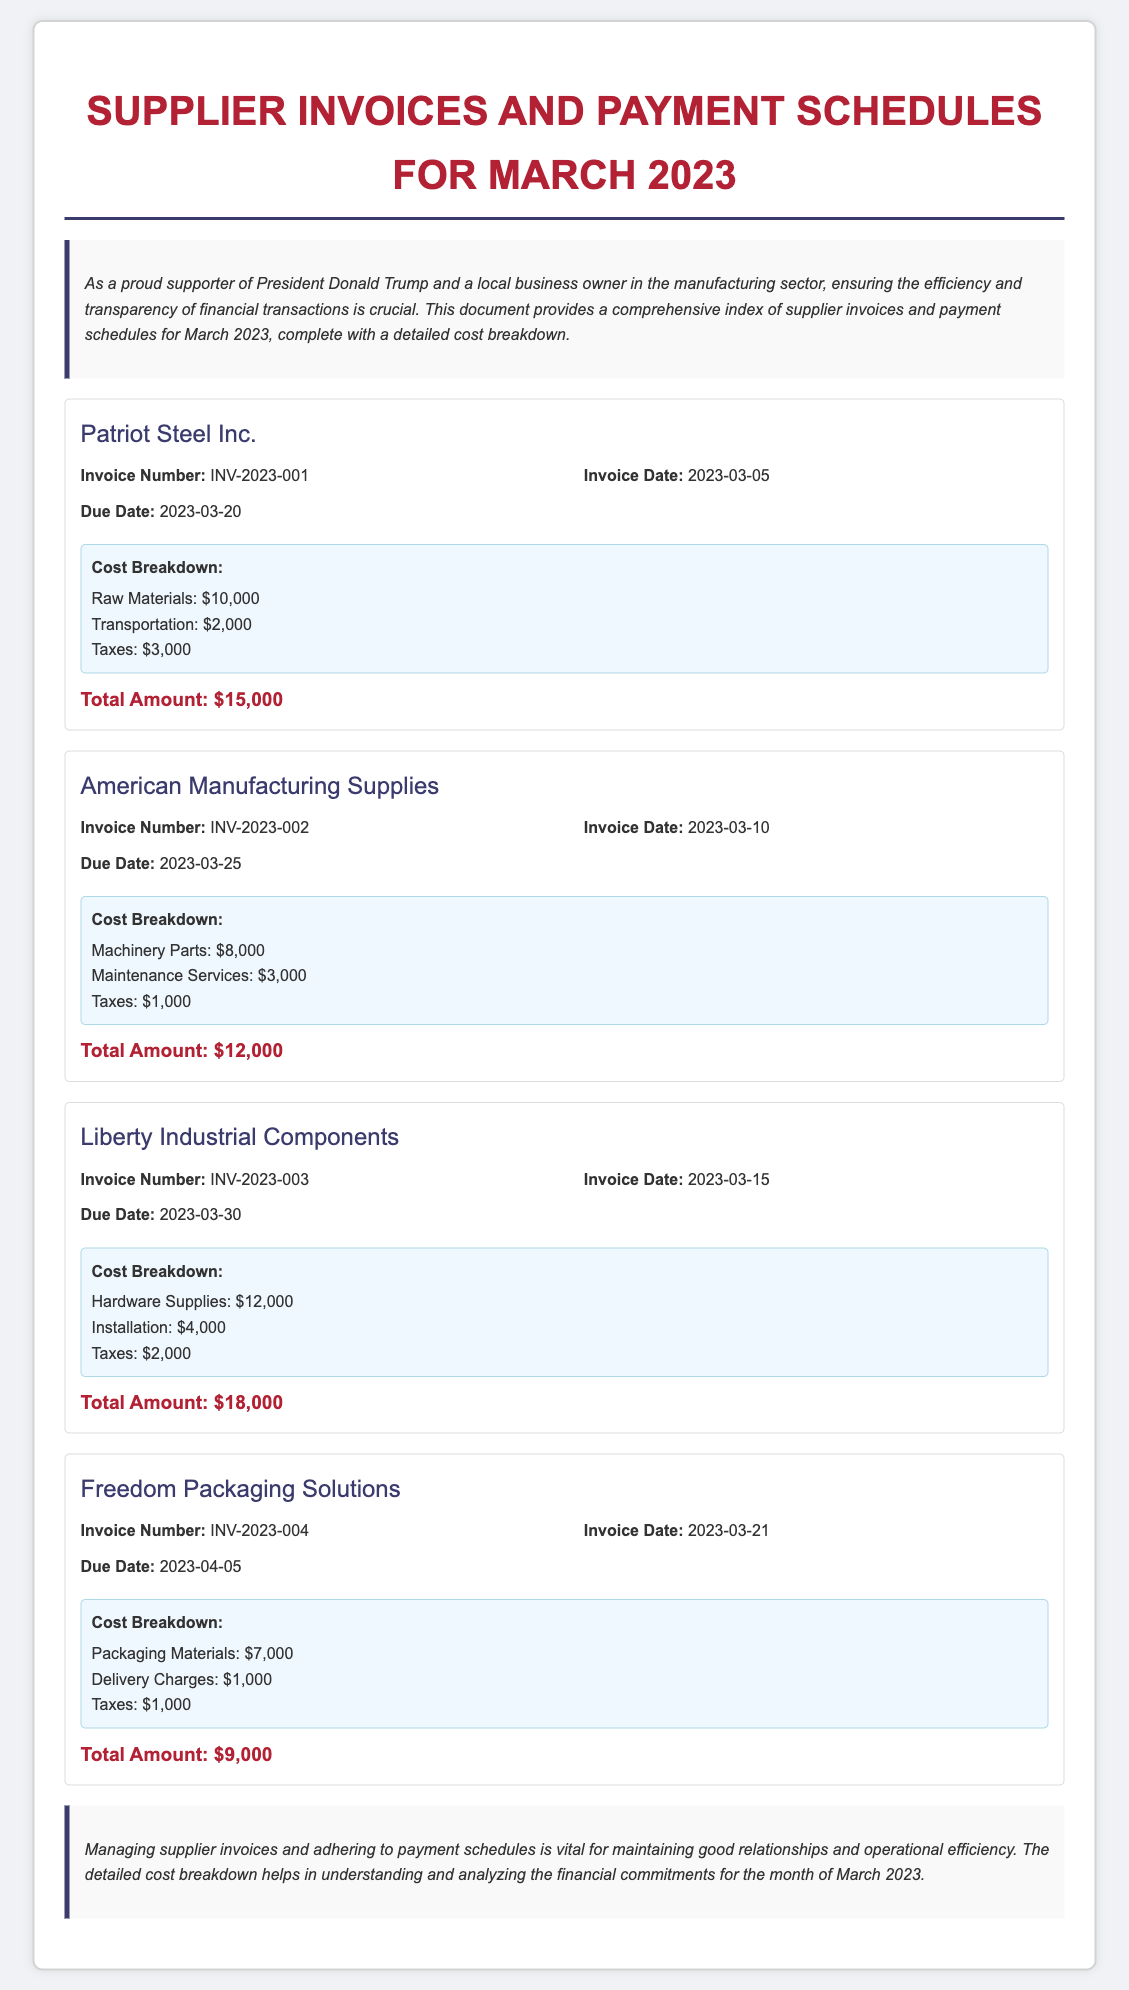What is the total amount for Patriot Steel Inc.? The total amount for Patriot Steel Inc. is provided in the document under the cost breakdown section, which is $15,000.
Answer: $15,000 What is the invoice date for American Manufacturing Supplies? The invoice date for American Manufacturing Supplies is stated under the invoice details, which is 2023-03-10.
Answer: 2023-03-10 What is the due date for Freedom Packaging Solutions? The due date for Freedom Packaging Solutions is listed in the invoice details, which is 2023-04-05.
Answer: 2023-04-05 How much did Liberty Industrial Components charge for installation? The charge for installation by Liberty Industrial Components is included in the cost breakdown section, which is $4,000.
Answer: $4,000 What is the total amount across all suppliers? The total amount is the sum of all the individual total amounts listed for each supplier, which is $15,000 + $12,000 + $18,000 + $9,000 = $54,000.
Answer: $54,000 What is noted about managing supplier invoices? The document mentions the importance of managing supplier invoices for maintaining good relationships and operational efficiency.
Answer: Vital for maintaining good relationships and operational efficiency How many suppliers are listed in the document? The number of suppliers is found by counting the distinct supplier sections provided, which totals to four suppliers.
Answer: Four What is the invoice number for Liberty Industrial Components? The invoice number for Liberty Industrial Components can be found in the invoice details section, which is INV-2023-003.
Answer: INV-2023-003 